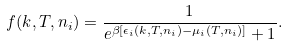Convert formula to latex. <formula><loc_0><loc_0><loc_500><loc_500>f ( k , T , n _ { i } ) = \frac { 1 } { e ^ { \beta [ \epsilon _ { i } ( k , T , n _ { i } ) - \mu _ { i } ( T , n _ { i } ) ] } + 1 } .</formula> 